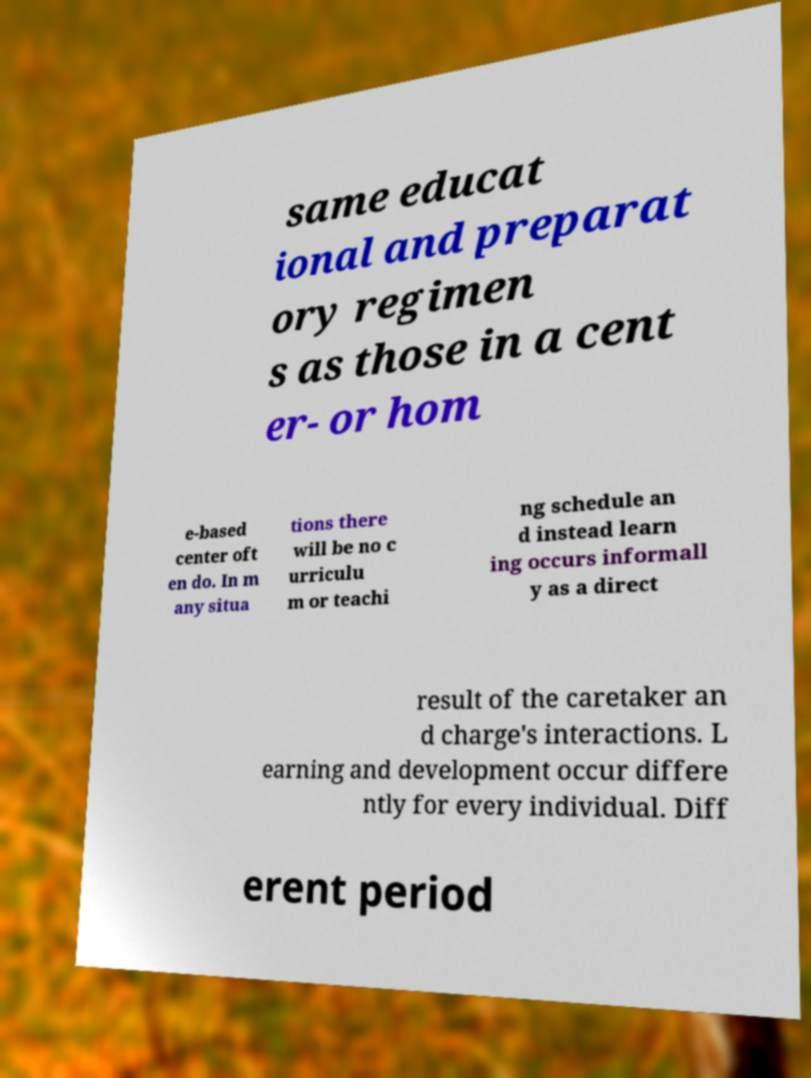Could you assist in decoding the text presented in this image and type it out clearly? same educat ional and preparat ory regimen s as those in a cent er- or hom e-based center oft en do. In m any situa tions there will be no c urriculu m or teachi ng schedule an d instead learn ing occurs informall y as a direct result of the caretaker an d charge's interactions. L earning and development occur differe ntly for every individual. Diff erent period 